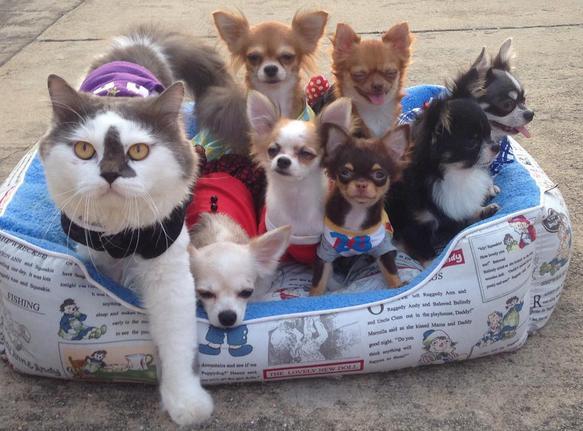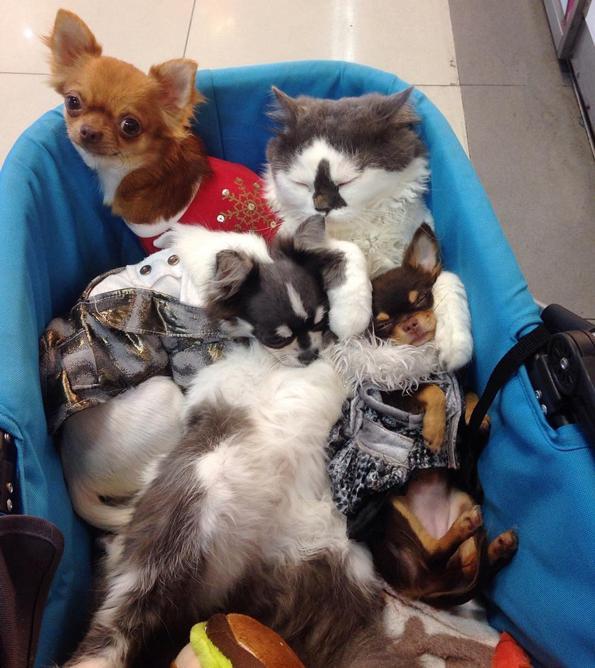The first image is the image on the left, the second image is the image on the right. Assess this claim about the two images: "The sleeping cat is snuggling with a dog in the image on the right.". Correct or not? Answer yes or no. Yes. 